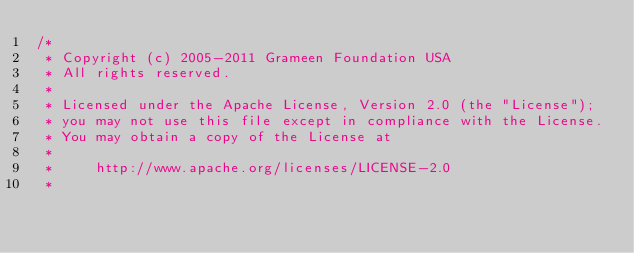<code> <loc_0><loc_0><loc_500><loc_500><_Java_>/*
 * Copyright (c) 2005-2011 Grameen Foundation USA
 * All rights reserved.
 *
 * Licensed under the Apache License, Version 2.0 (the "License");
 * you may not use this file except in compliance with the License.
 * You may obtain a copy of the License at
 *
 *     http://www.apache.org/licenses/LICENSE-2.0
 *</code> 